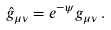Convert formula to latex. <formula><loc_0><loc_0><loc_500><loc_500>\hat { g } _ { \mu \nu } = e ^ { - \psi } g _ { \mu \nu } \, .</formula> 